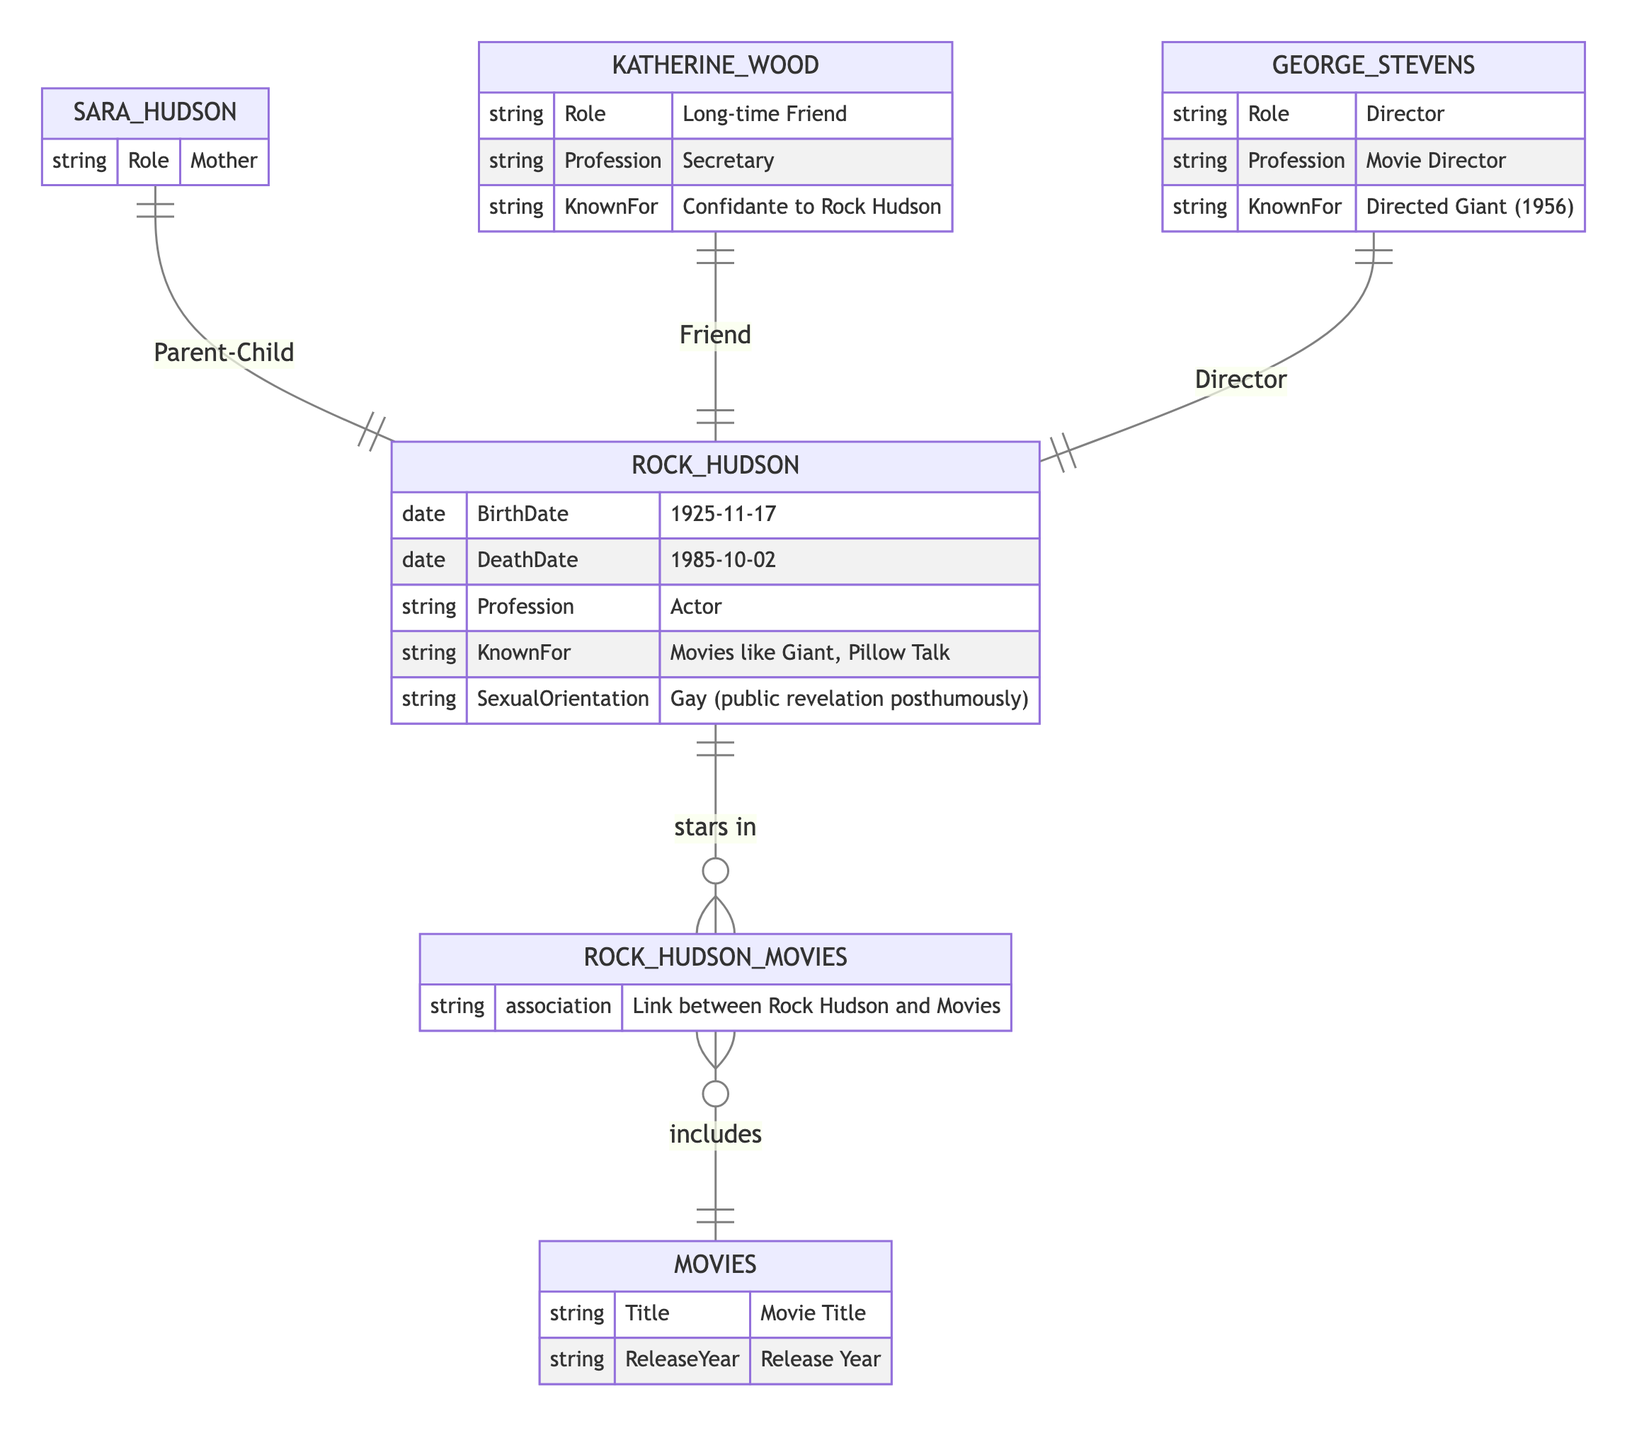What is Rock Hudson's profession? The diagram indicates that Rock Hudson is labeled with the attribute "Profession" which is stated as "Actor" under his entity. Thus, we can directly refer to the attribute to answer.
Answer: Actor Who directed the movie Giant? George Stevens is linked to Rock Hudson with the relationship type "Director" and his known for directing the movie "Giant (1956)", making him the director of that film.
Answer: George Stevens How many movies are associated with Rock Hudson? The relationship "stars in" links Rock Hudson to the entity "Rock Hudson Movies", which then connects to "Movies". The entity diagram shows an association but does not specify a count, so we can only infer that there may be multiple movies related through this association. Thus, we refer to the relationship type for the general understanding rather than a specific quantity.
Answer: Multiple What is Sara Hudson's role in relation to Rock Hudson? The diagram specifies a direct relationship labeled as "Parent-Child" between Sara Hudson and Rock Hudson, which clarifies her role as his mother.
Answer: Mother What type of relationship exists between Katherine Wood and Rock Hudson? The diagram details a relationship labeled "Friend" between Katherine Wood and Rock Hudson, indicating their connection.
Answer: Friendship What profession is associated with Katherine Wood? Katherine Wood's entity lists her profession as "Secretary". This attribute directly answers the question regarding her profession.
Answer: Secretary What is the release year attribute in the Movies entity? The "Movies" entity has an attribute labeled "ReleaseYear", which indicates that this entity is focused on movie-specific data including the release year but does not provide a specific date in this entity.
Answer: Release Year What role does George Stevens have in relation to Rock Hudson? George Stevens has a defined relationship labeled "Director" with Rock Hudson, which outlines his professional relationship as a director to the actor.
Answer: Director What is the known for attribute of Rock Hudson? According to the diagram, under Rock Hudson's attributes, the "KnownFor" field states "Movies like Giant, Pillow Talk", showcasing his notable works.
Answer: Movies like Giant, Pillow Talk 